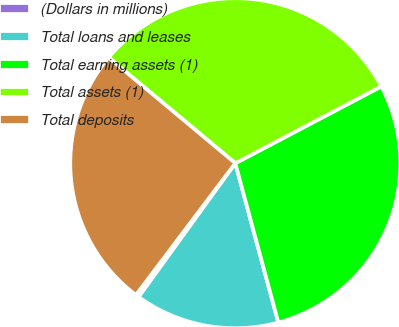Convert chart. <chart><loc_0><loc_0><loc_500><loc_500><pie_chart><fcel>(Dollars in millions)<fcel>Total loans and leases<fcel>Total earning assets (1)<fcel>Total assets (1)<fcel>Total deposits<nl><fcel>0.32%<fcel>14.16%<fcel>28.51%<fcel>31.22%<fcel>25.79%<nl></chart> 